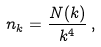<formula> <loc_0><loc_0><loc_500><loc_500>n _ { k } = \frac { N ( k ) } { k ^ { 4 } } \, ,</formula> 